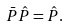Convert formula to latex. <formula><loc_0><loc_0><loc_500><loc_500>\bar { P } \hat { P } = \hat { P } .</formula> 